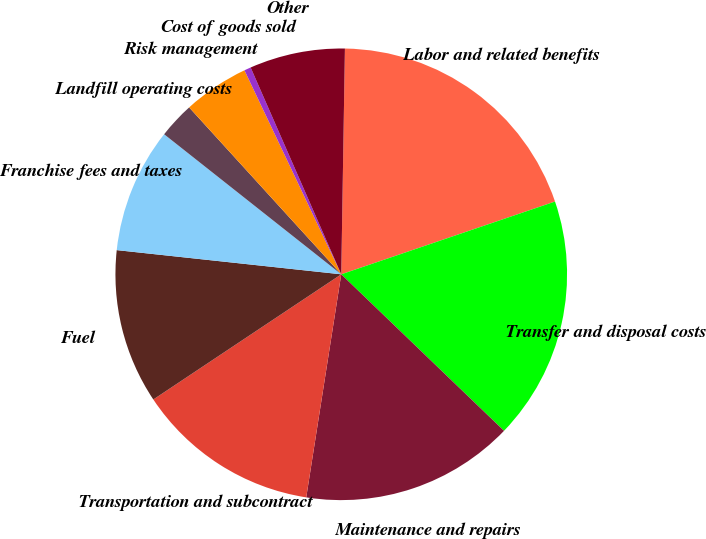Convert chart. <chart><loc_0><loc_0><loc_500><loc_500><pie_chart><fcel>Labor and related benefits<fcel>Transfer and disposal costs<fcel>Maintenance and repairs<fcel>Transportation and subcontract<fcel>Fuel<fcel>Franchise fees and taxes<fcel>Landfill operating costs<fcel>Risk management<fcel>Cost of goods sold<fcel>Other<nl><fcel>19.52%<fcel>17.41%<fcel>15.29%<fcel>13.17%<fcel>11.06%<fcel>8.94%<fcel>2.59%<fcel>4.71%<fcel>0.48%<fcel>6.83%<nl></chart> 